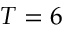Convert formula to latex. <formula><loc_0><loc_0><loc_500><loc_500>T = 6</formula> 